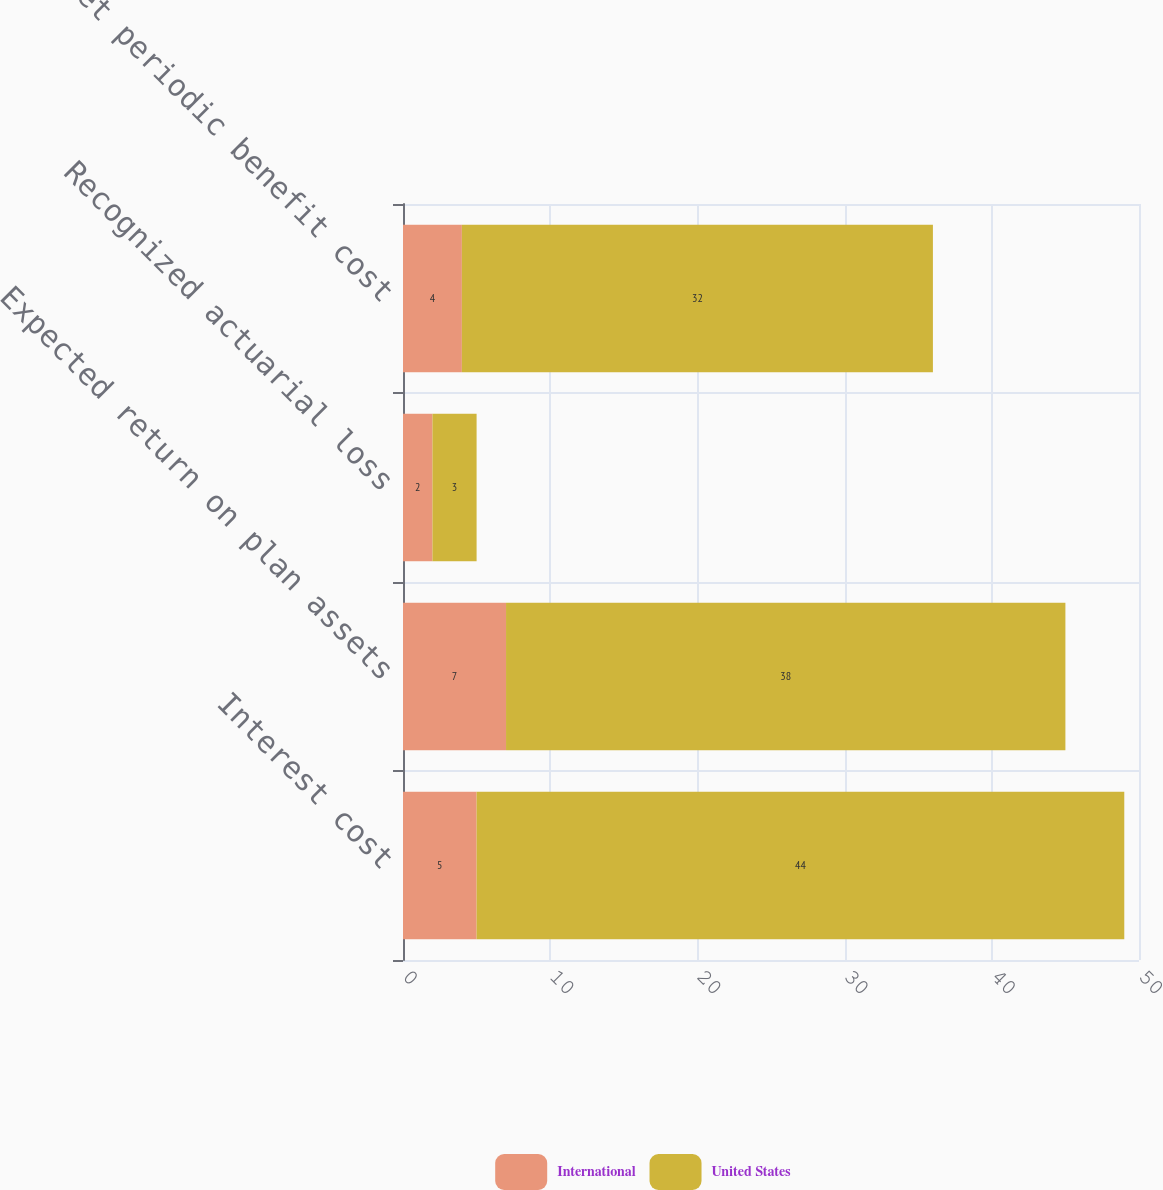Convert chart. <chart><loc_0><loc_0><loc_500><loc_500><stacked_bar_chart><ecel><fcel>Interest cost<fcel>Expected return on plan assets<fcel>Recognized actuarial loss<fcel>Net periodic benefit cost<nl><fcel>International<fcel>5<fcel>7<fcel>2<fcel>4<nl><fcel>United States<fcel>44<fcel>38<fcel>3<fcel>32<nl></chart> 